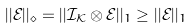<formula> <loc_0><loc_0><loc_500><loc_500>| | \mathcal { E } | | _ { \diamond } = | | \mathcal { I } _ { \mathcal { K } } \otimes \mathcal { E } | | _ { 1 } \geq | | \mathcal { E } | | _ { 1 }</formula> 